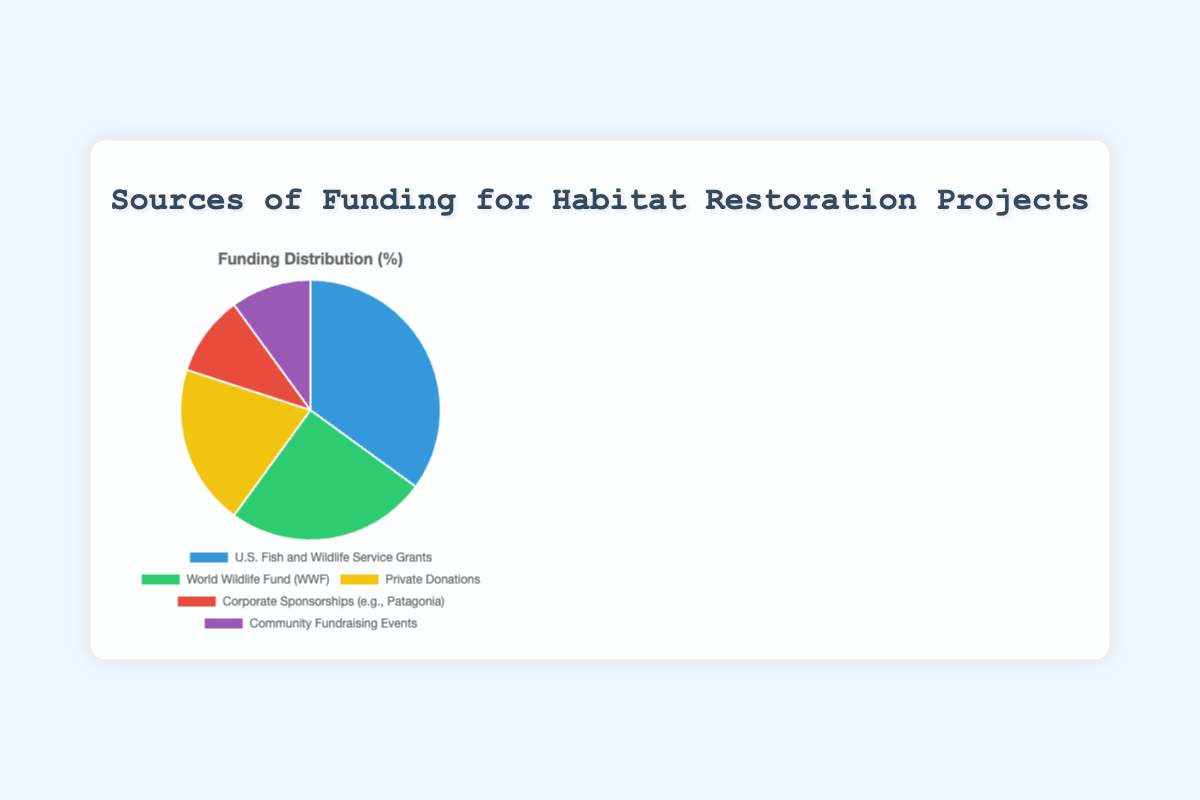What percentage of funding comes from corporate sponsorships? The pie chart shows different sources of funding along with their respective percentages. Corporate sponsorships are shown to contribute a specific portion.
Answer: 10% What is the combined percentage of funding from private donations and community fundraising events? To find the combined percentage, sum the individual percentages of private donations (20%) and community fundraising events (10%). Thus, 20% + 10% = 30%.
Answer: 30% How much more funding does the U.S. Fish and Wildlife Service provide compared to the World Wildlife Fund? The percentage of funding from the U.S. Fish and Wildlife Service is 35%, while the World Wildlife Fund provides 25%. The difference is calculated as 35% - 25% = 10%.
Answer: 10% Which funding source contributes the least and what percentage does it provide? By comparing all listed percentages, the sources with the smallest contributions are corporate sponsorships and community fundraising events, both providing 10%.
Answer: Corporate Sponsorships and Community Fundraising Events, 10% Is the percentage of funding from the World Wildlife Fund greater than 20%? The World Wildlife Fund contributes 25%, which is greater than 20%.
Answer: Yes What fraction of the funding comes from NGO sources (like the World Wildlife Fund)? The World Wildlife Fund provides 25% of the funding. This can be expressed as a fraction, 25/100, which simplifies to 1/4.
Answer: 1/4 What is the total percentage of funding from sources other than the U.S. Fish and Wildlife Service Grants? The percentage from the U.S. Fish and Wildlife Service grants is 35%. The contribution from other sources is 100% - 35% = 65%.
Answer: 65% Which funding source uses a green color in the pie chart? The specific colors representing each source can be identified visually. The green color corresponds to the World Wildlife Fund (WWF).
Answer: World Wildlife Fund Are the contributions from private donations and corporate sponsorships equal? Private donations contribute 20%, whereas corporate sponsorships contribute 10%. They are not equal.
Answer: No What is the average percentage of funding from the World Wildlife Fund and the U.S. Fish and Wildlife Service? The World Wildlife Fund provides 25% and the U.S. Fish and Wildlife Service provides 35%. The average is calculated as (25% + 35%) / 2 = 30%.
Answer: 30% 